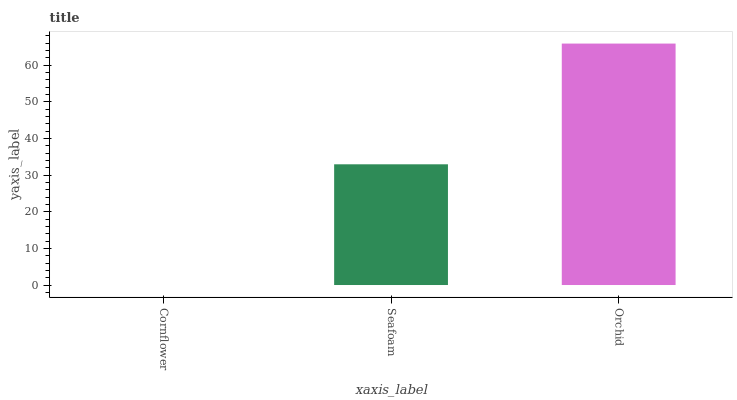Is Cornflower the minimum?
Answer yes or no. Yes. Is Orchid the maximum?
Answer yes or no. Yes. Is Seafoam the minimum?
Answer yes or no. No. Is Seafoam the maximum?
Answer yes or no. No. Is Seafoam greater than Cornflower?
Answer yes or no. Yes. Is Cornflower less than Seafoam?
Answer yes or no. Yes. Is Cornflower greater than Seafoam?
Answer yes or no. No. Is Seafoam less than Cornflower?
Answer yes or no. No. Is Seafoam the high median?
Answer yes or no. Yes. Is Seafoam the low median?
Answer yes or no. Yes. Is Orchid the high median?
Answer yes or no. No. Is Cornflower the low median?
Answer yes or no. No. 